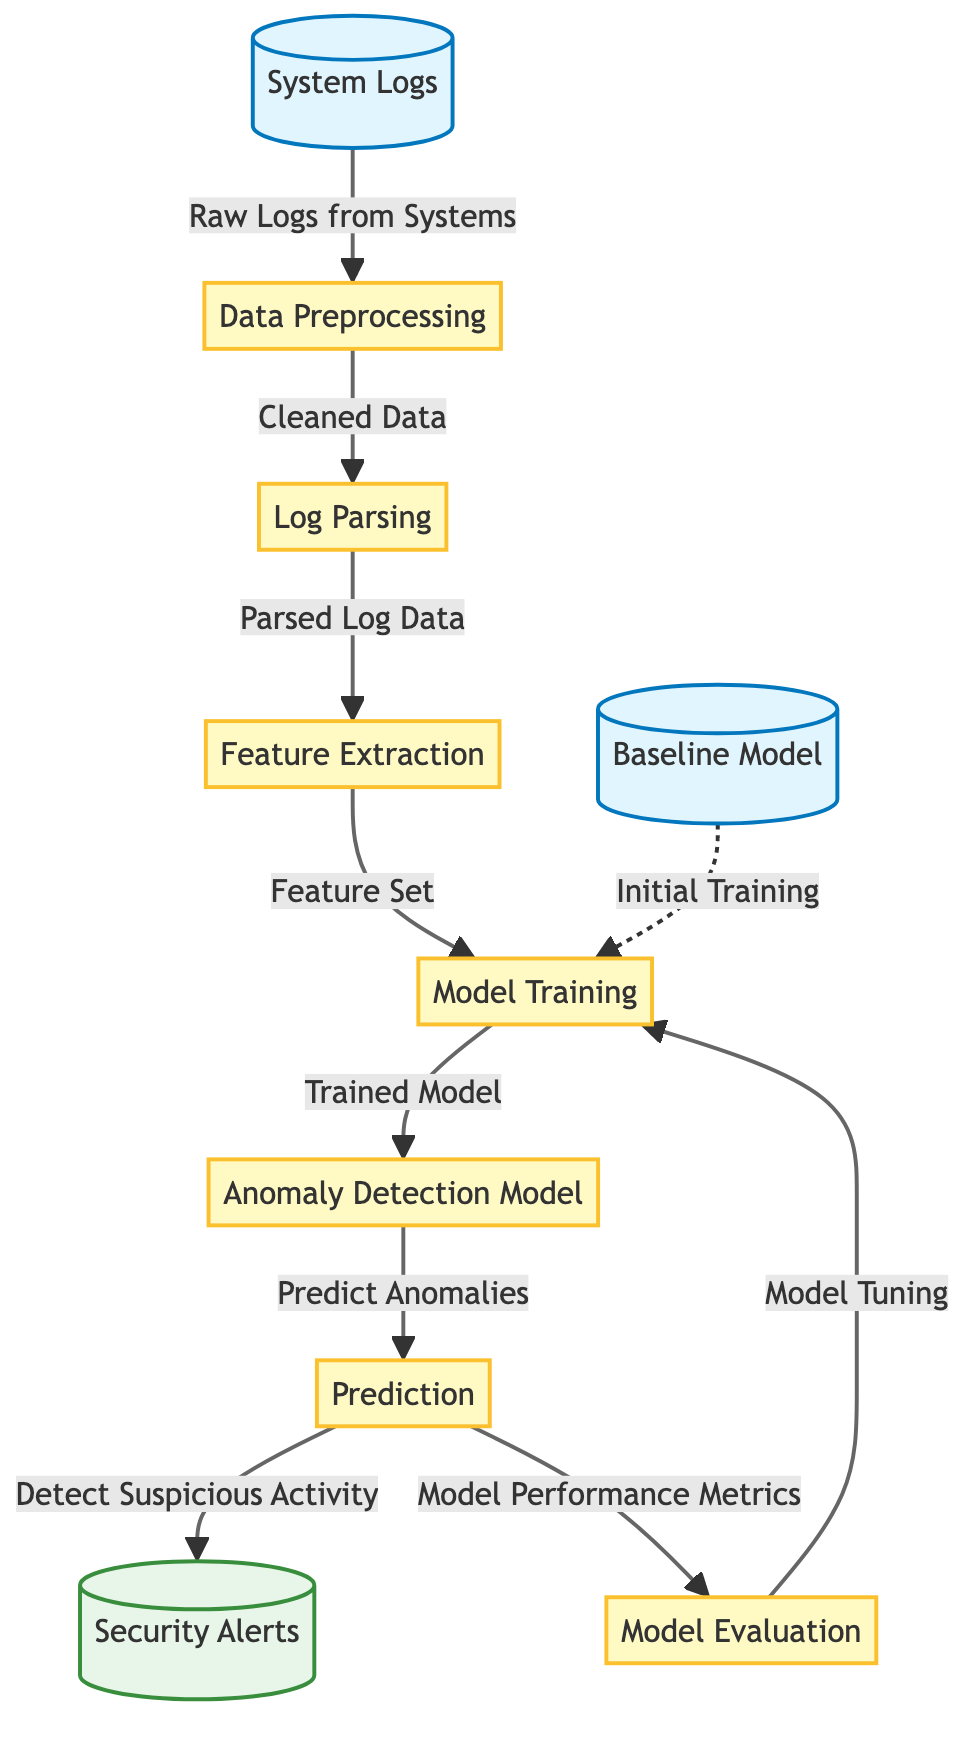What is the first node in the diagram? The first node listed in the diagram is "System Logs," which is indicated as the starting point of the process.
Answer: System Logs How many processes are represented in the diagram? By counting all the labeled nodes categorized as processes, there are five processes identified in this diagram.
Answer: 5 What is the output of the prediction stage? The prediction stage outputs two results: "Detect Suspicious Activity" and "Model Performance Metrics," which indicate the effects of the prediction process.
Answer: Detect Suspicious Activity, Model Performance Metrics What does the "Model Training" process produce? The "Model Training" process produces a "Trained Model," showing what the training yields before moving on to detecting anomalies.
Answer: Trained Model Which input node is connected as an initial training source? The input node labeled "Baseline Model" is connected to the "Model Training" process, serving as the initial training reference for the system.
Answer: Baseline Model How do cleaned data proceed after preprocessing? After data preprocessing, the cleaned data moves to the "Log Parsing" process, indicating the next stage in the data flow.
Answer: Log Parsing What feedback does "Model Evaluation" provide? "Model Evaluation" provides feedback for "Model Tuning," indicating that the evaluation results are used to enhance the model's effectiveness.
Answer: Model Tuning Which node deals with capturing raw logs? The "System Logs" node deals with capturing raw logs, as it represents the input source for the entire process flow in the diagram.
Answer: System Logs What does the anomaly detection model do? The anomaly detection model's role is to "Predict Anomalies," which refers to its main function in identifying potential security threats.
Answer: Predict Anomalies 